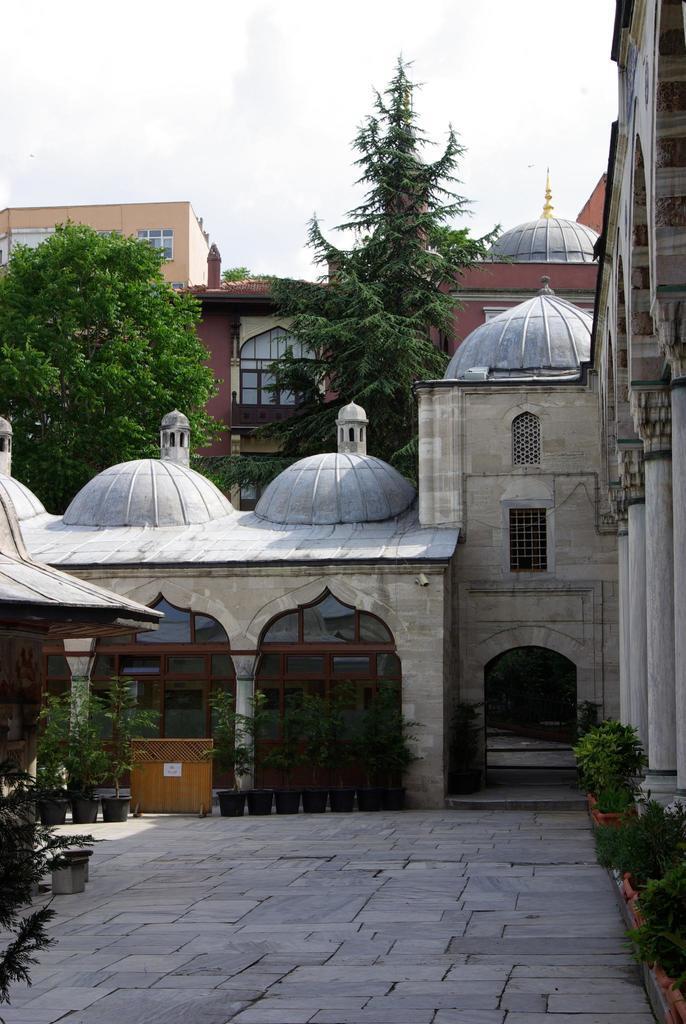Please provide a concise description of this image. In this picture I can see the path on which there are number of plants and in the middle of this picture I can see number of buildings and trees. In the background I can see the sky. 